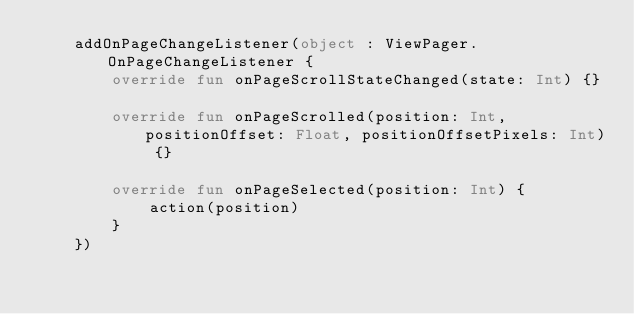Convert code to text. <code><loc_0><loc_0><loc_500><loc_500><_Kotlin_>    addOnPageChangeListener(object : ViewPager.OnPageChangeListener {
        override fun onPageScrollStateChanged(state: Int) {}

        override fun onPageScrolled(position: Int, positionOffset: Float, positionOffsetPixels: Int) {}

        override fun onPageSelected(position: Int) {
            action(position)
        }
    })
</code> 